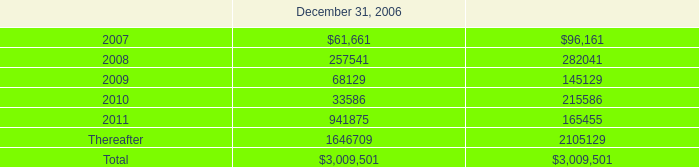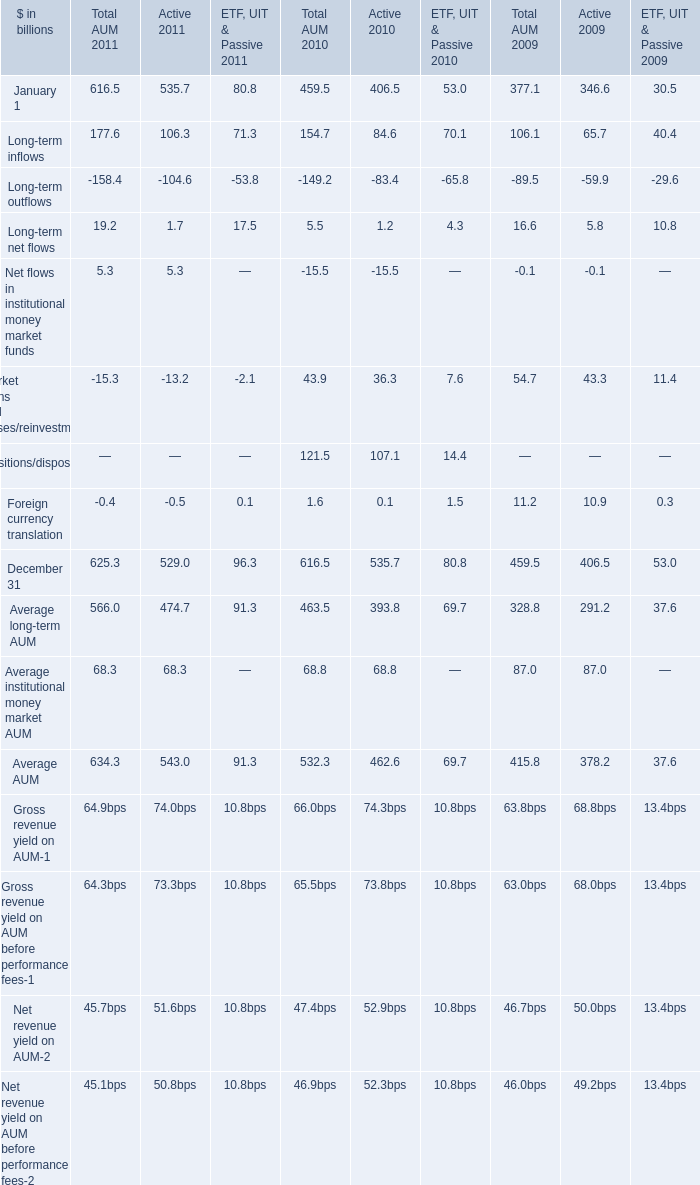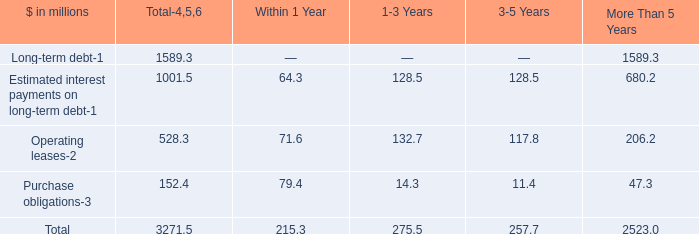Does Average AUM keeps increasing each year between 2009 and 2011? 
Answer: yes. 